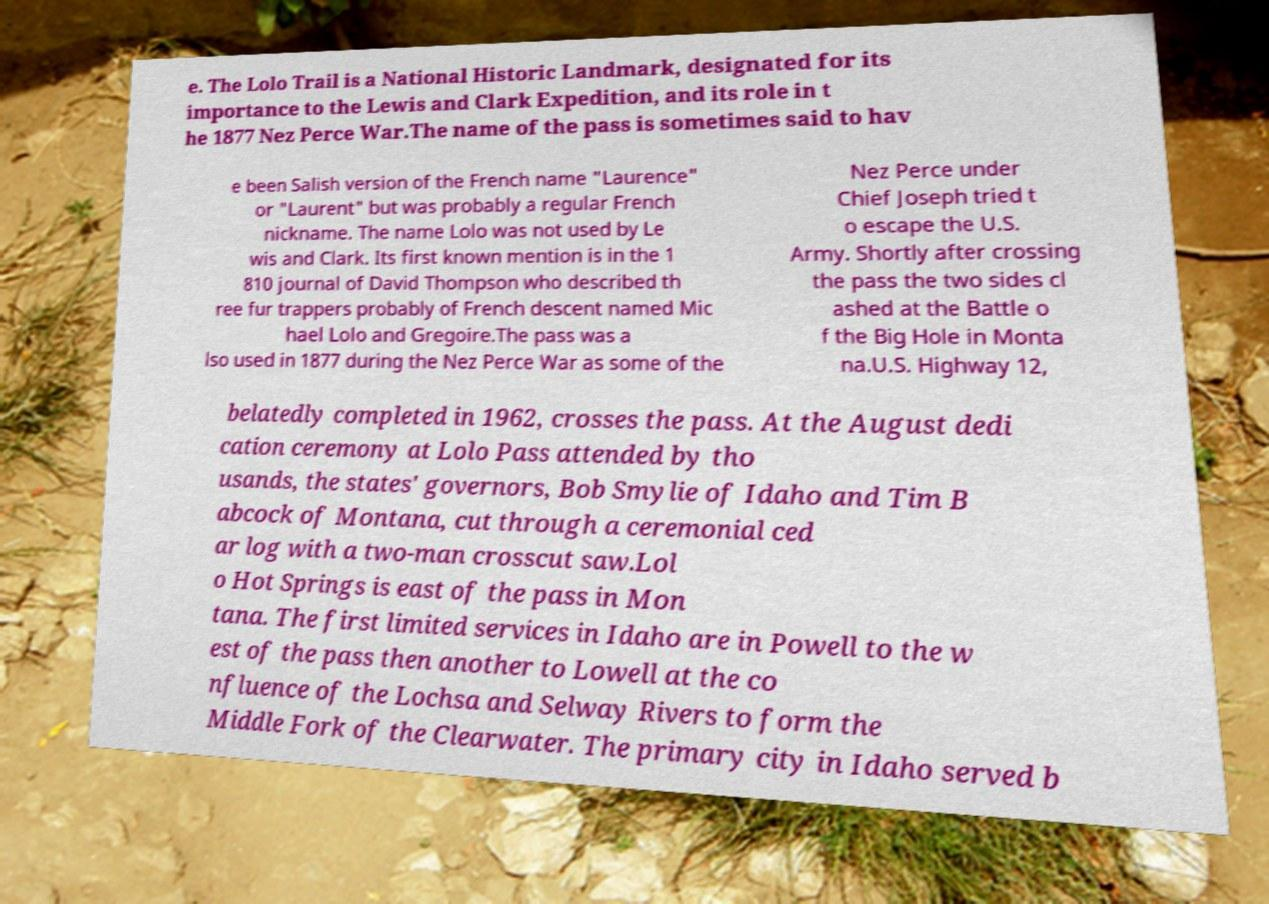Can you accurately transcribe the text from the provided image for me? e. The Lolo Trail is a National Historic Landmark, designated for its importance to the Lewis and Clark Expedition, and its role in t he 1877 Nez Perce War.The name of the pass is sometimes said to hav e been Salish version of the French name "Laurence" or "Laurent" but was probably a regular French nickname. The name Lolo was not used by Le wis and Clark. Its first known mention is in the 1 810 journal of David Thompson who described th ree fur trappers probably of French descent named Mic hael Lolo and Gregoire.The pass was a lso used in 1877 during the Nez Perce War as some of the Nez Perce under Chief Joseph tried t o escape the U.S. Army. Shortly after crossing the pass the two sides cl ashed at the Battle o f the Big Hole in Monta na.U.S. Highway 12, belatedly completed in 1962, crosses the pass. At the August dedi cation ceremony at Lolo Pass attended by tho usands, the states' governors, Bob Smylie of Idaho and Tim B abcock of Montana, cut through a ceremonial ced ar log with a two-man crosscut saw.Lol o Hot Springs is east of the pass in Mon tana. The first limited services in Idaho are in Powell to the w est of the pass then another to Lowell at the co nfluence of the Lochsa and Selway Rivers to form the Middle Fork of the Clearwater. The primary city in Idaho served b 